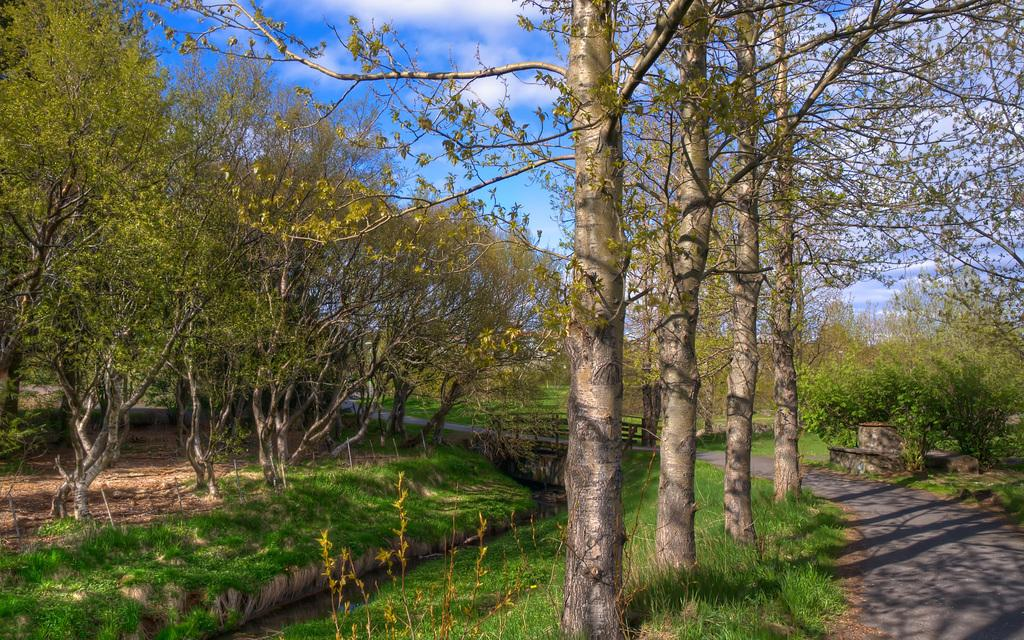What type of vegetation can be seen in the image? There are trees and plants visible in the image. What type of ground cover is present in the image? There is grass visible in the image. What type of man-made structure is present in the image? There is a road visible in the image. What type of natural feature is present in the image? There is water visible in the image. What is visible in the background of the image? The sky is visible in the background of the image. What is the condition of the sky in the image? The sky has clouds visible in it. What holiday is being celebrated in the image? There is no indication of a holiday being celebrated in the image. What type of brake is visible on the road in the image? There is no brake visible on the road in the image. 